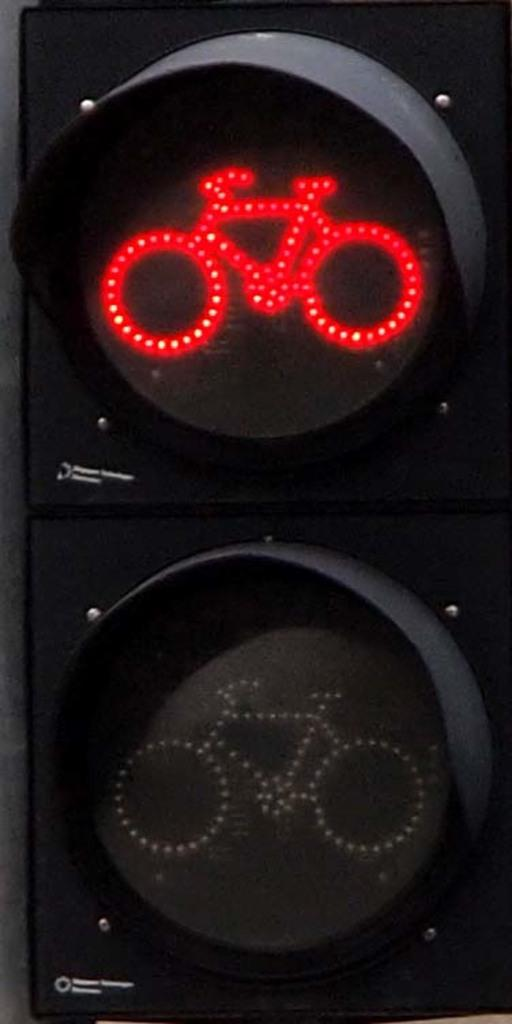What is the main subject in the center of the image? There is a traffic signal in the center of the image. What type of transportation is depicted in the image? There are depictions of bicycles in the image. What other objects can be seen in the image? There are other objects depicted in the image. What type of fang can be seen in the image? There is no fang present in the image. What belief is represented by the objects in the image? The image does not depict any beliefs; it shows a traffic signal and bicycles. 